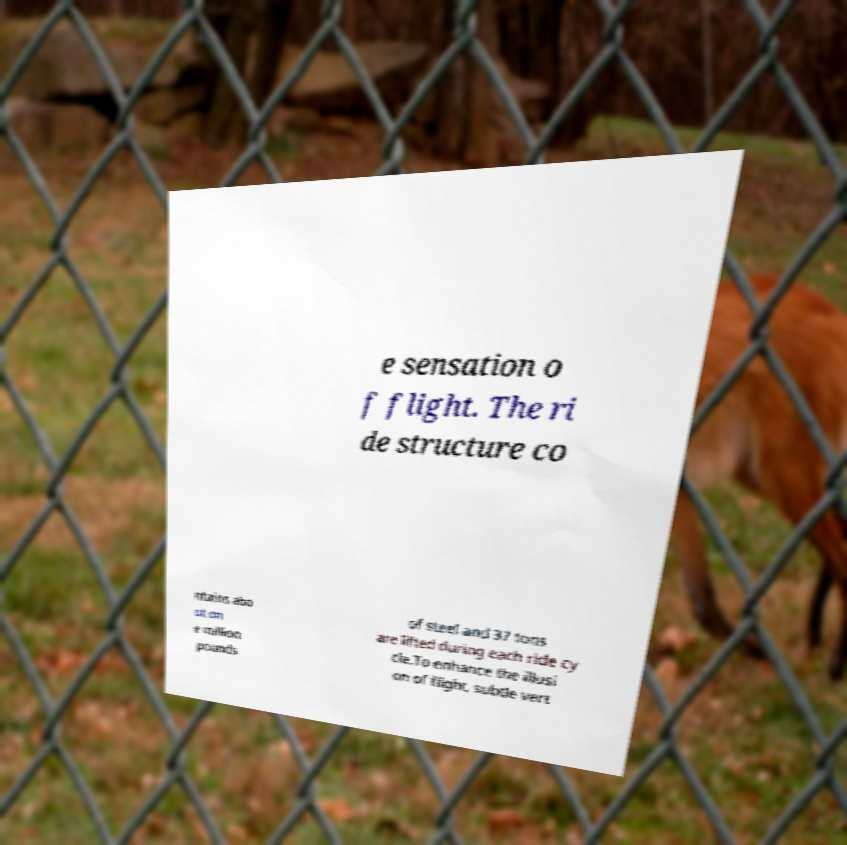Could you extract and type out the text from this image? e sensation o f flight. The ri de structure co ntains abo ut on e million pounds of steel and 37 tons are lifted during each ride cy cle.To enhance the illusi on of flight, subtle vert 